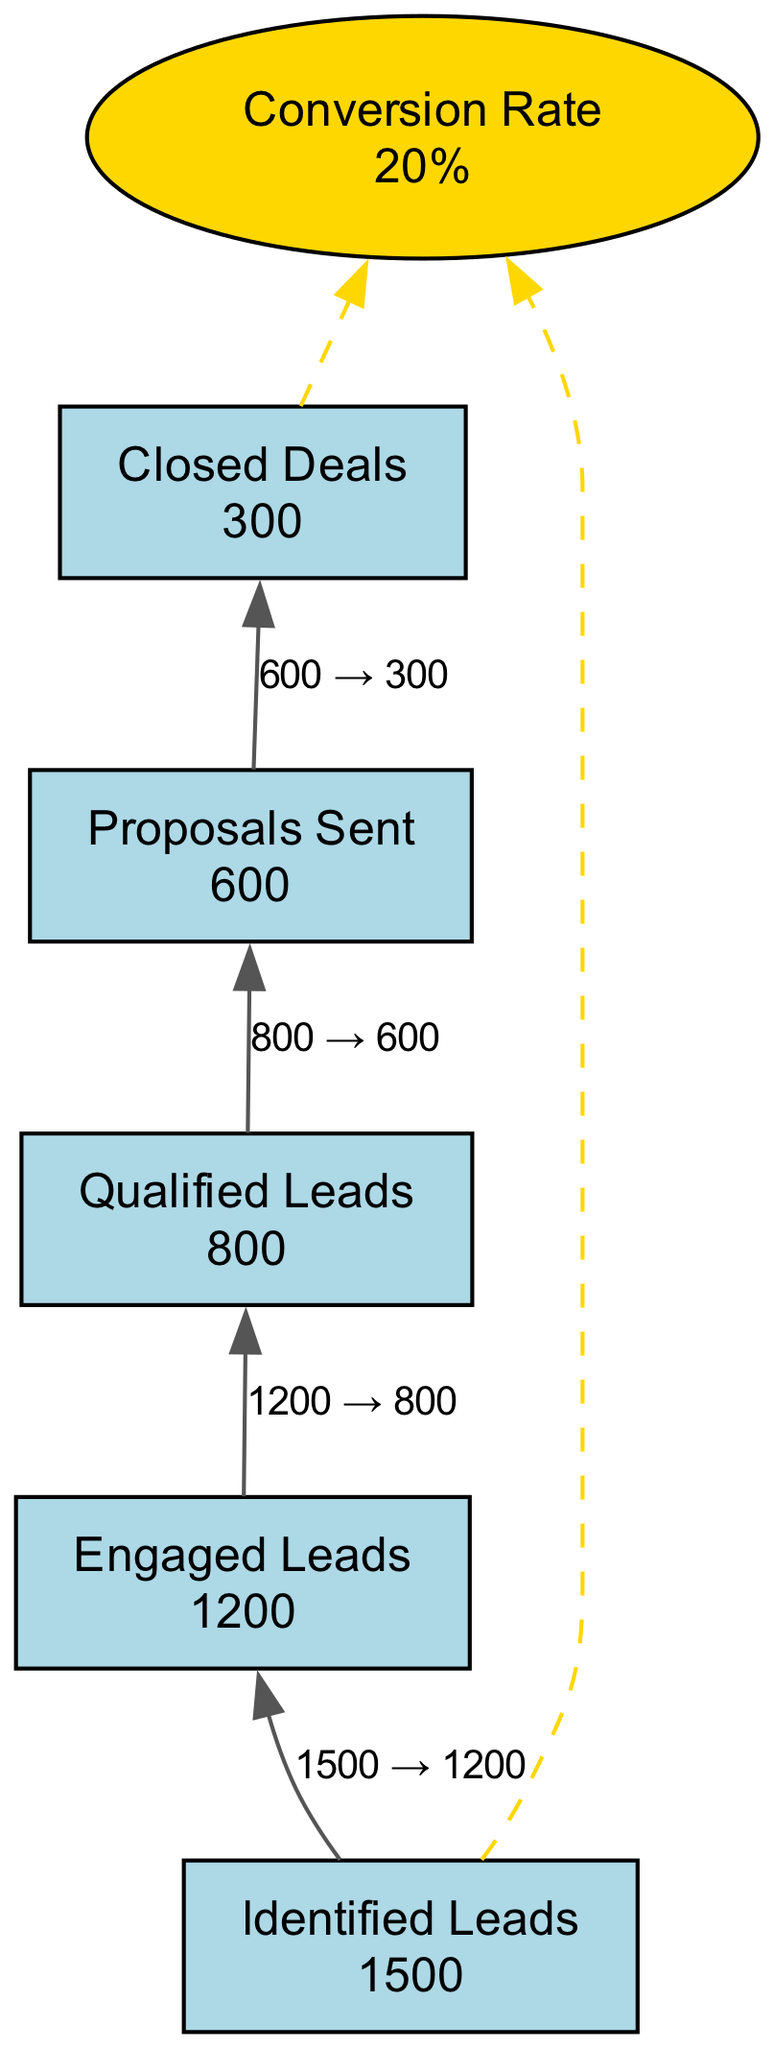What is the total number of identified leads in Q1 2023? From the diagram, the node labeled "Identified Leads" shows a value of 1500, which directly represents the total number of leads identified for Q1 2023.
Answer: 1500 How many leads were engaged during Q1 2023? The node titled "Engaged Leads" specifies that 1200 leads were contacted or interacted with during the quarter, which is the value shown in the diagram.
Answer: 1200 What is the conversion rate from identified leads to closed deals? The conversion rate shown at the end of the diagram calculated as (Closed Deals / Identified Leads) * 100 is stated to be 20%, which means that 20% of the identified leads were converted into closed deals.
Answer: 20% How many proposals were sent to qualified leads? According to the "Proposals Sent" node, the value is 600, indicating the total number of proposals sent to the leads that qualified after engagement.
Answer: 600 What is the relationship between Engaged Leads and Qualified Leads? The diagram flows from "Engaged Leads" to "Qualified Leads," indicating that after engagement, only 800 leads out of the 1200 engaged were deemed qualified. This means that the flow contributes to understanding how leads were filtered.
Answer: 800 How many closed deals were achieved in Q1 2023? The "Closed Deals" node indicates that there were 300 deals successfully closed in Q1 2023, which can be directly read from the diagram.
Answer: 300 Which node has the highest value in this flow chart? The "Identified Leads" node has the highest value of 1500, representing the start of the funnel, making it the node with the highest numerical value within the flow chart.
Answer: 1500 How does the number of Closed Deals relate to the number of Proposed Sent? The flow in the diagram shows an edge from "Proposals Sent" to "Closed Deals," indicating that out of the 600 proposals sent, 300 resulted in closed deals, demonstrating a successful conversion from proposals to deals.
Answer: 300 What shape is used for the Conversion Rate node? The Conversion Rate node is depicted in an ellipse shape as indicated by the attributes defined in the diagram, differentiating it from other nodes which are rectangles.
Answer: Ellipse 